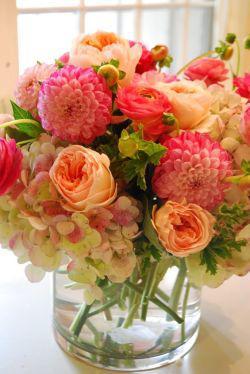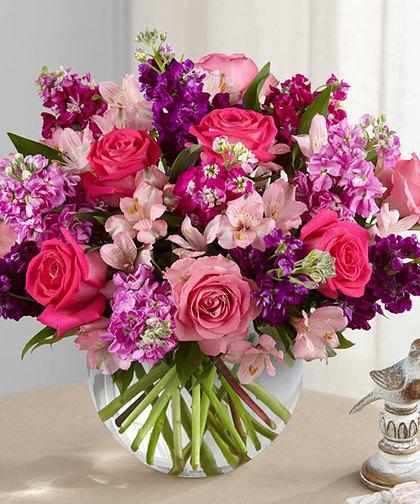The first image is the image on the left, the second image is the image on the right. Considering the images on both sides, is "One image shows a transparent cylindrical vase with pebble-shaped objects inside, holding a bouquet of pink roses and ruffly white flowers." valid? Answer yes or no. No. The first image is the image on the left, the second image is the image on the right. Given the left and right images, does the statement "There are stones at the bottom of one of the vases." hold true? Answer yes or no. No. 